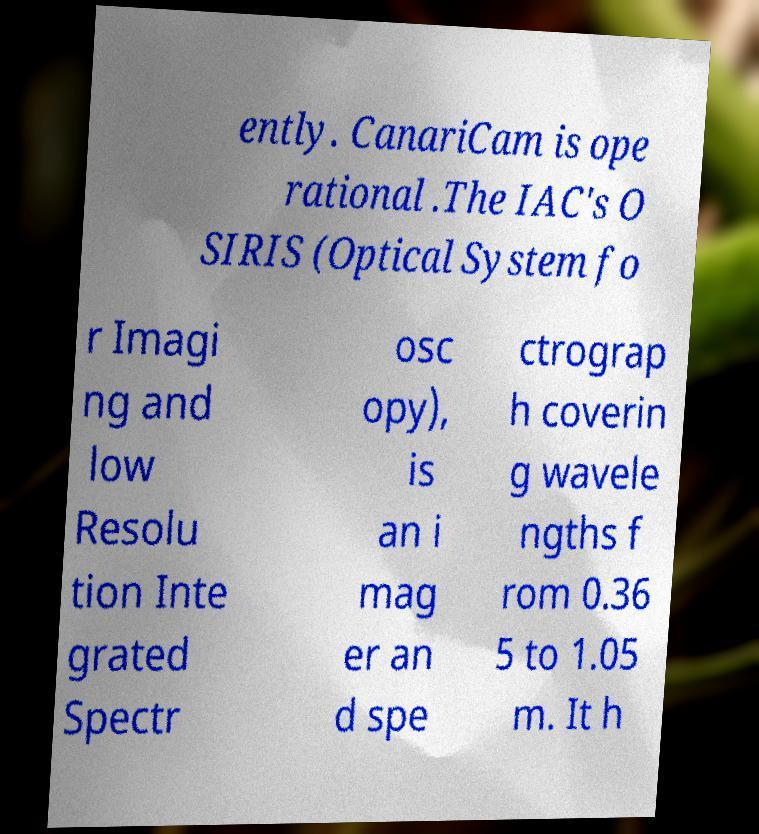I need the written content from this picture converted into text. Can you do that? ently. CanariCam is ope rational .The IAC's O SIRIS (Optical System fo r Imagi ng and low Resolu tion Inte grated Spectr osc opy), is an i mag er an d spe ctrograp h coverin g wavele ngths f rom 0.36 5 to 1.05 m. It h 